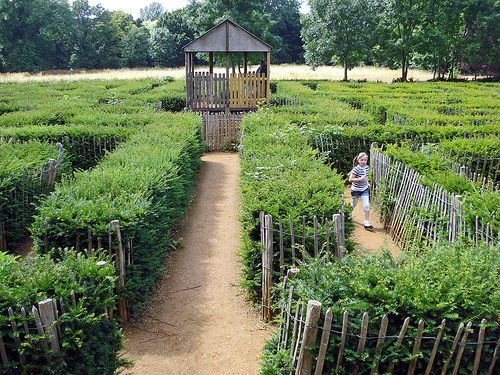<image>
Is the child next to the fence? Yes. The child is positioned adjacent to the fence, located nearby in the same general area. 